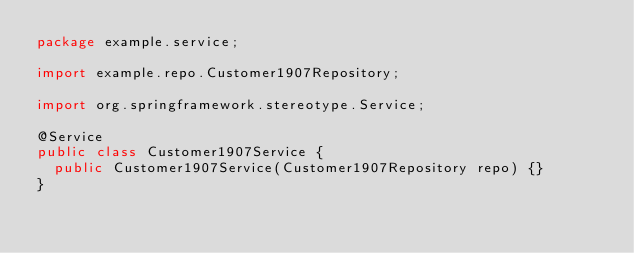<code> <loc_0><loc_0><loc_500><loc_500><_Java_>package example.service;

import example.repo.Customer1907Repository;

import org.springframework.stereotype.Service;

@Service
public class Customer1907Service {
	public Customer1907Service(Customer1907Repository repo) {}
}
</code> 